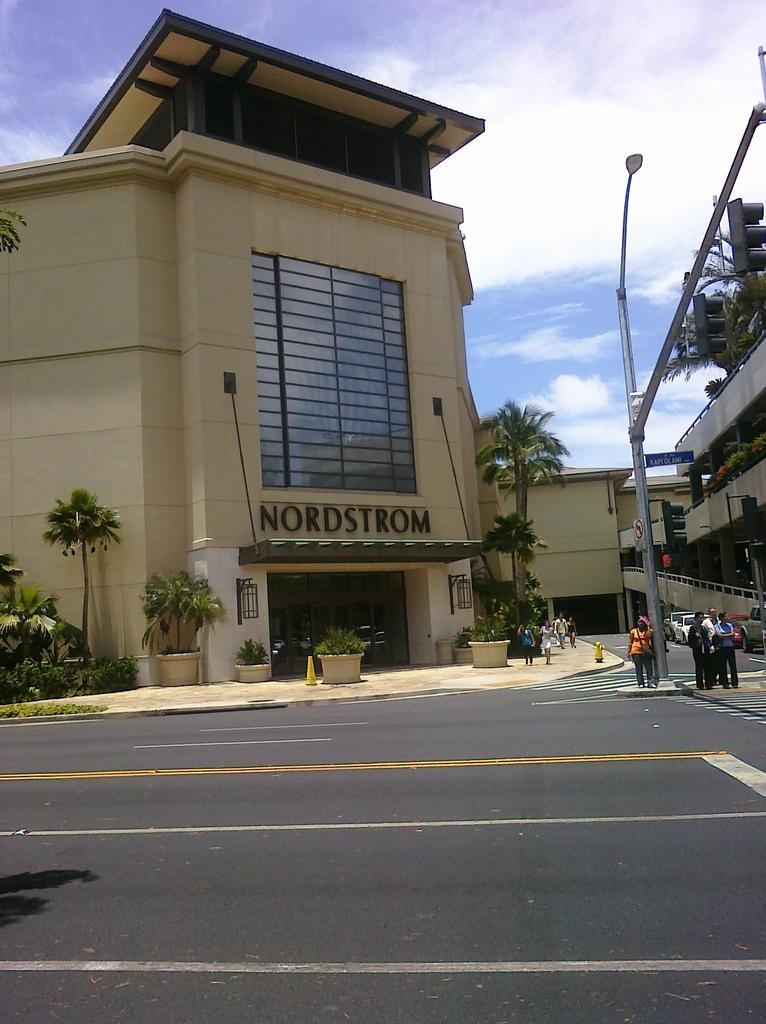What is the name of the store?
Your answer should be compact. Nordstrom. What color is the store?
Offer a very short reply. Beige. 